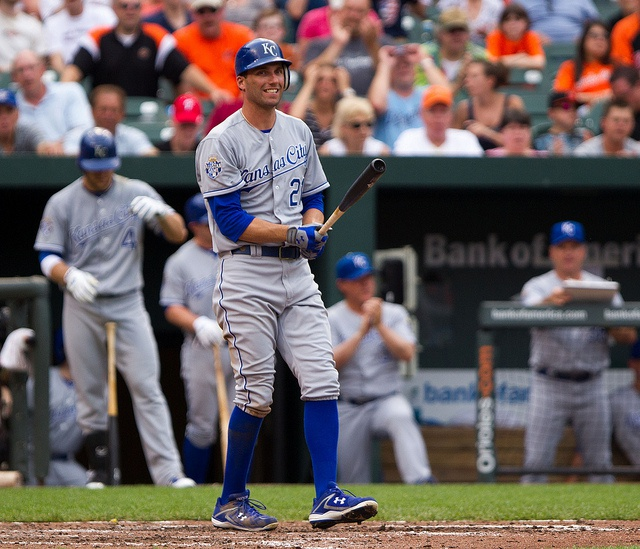Describe the objects in this image and their specific colors. I can see people in brown, black, gray, and lavender tones, people in brown, darkgray, lightgray, navy, and black tones, people in brown, darkgray, gray, and black tones, people in brown, gray, black, and darkgray tones, and people in brown, darkgray, and gray tones in this image. 